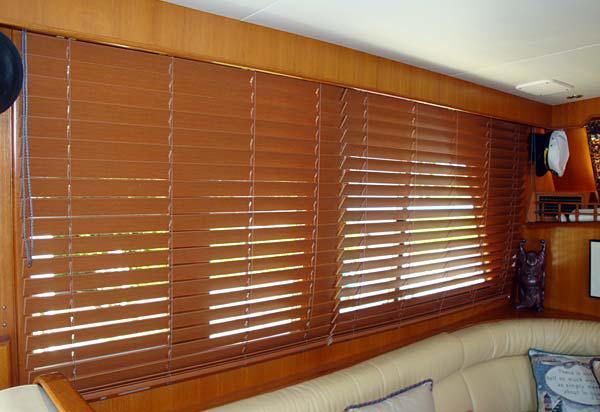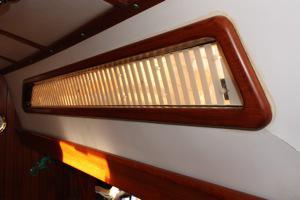The first image is the image on the left, the second image is the image on the right. For the images shown, is this caption "The window area in the image on the left has lights that are switched on." true? Answer yes or no. No. The first image is the image on the left, the second image is the image on the right. Examine the images to the left and right. Is the description "There is a total of five windows." accurate? Answer yes or no. No. 